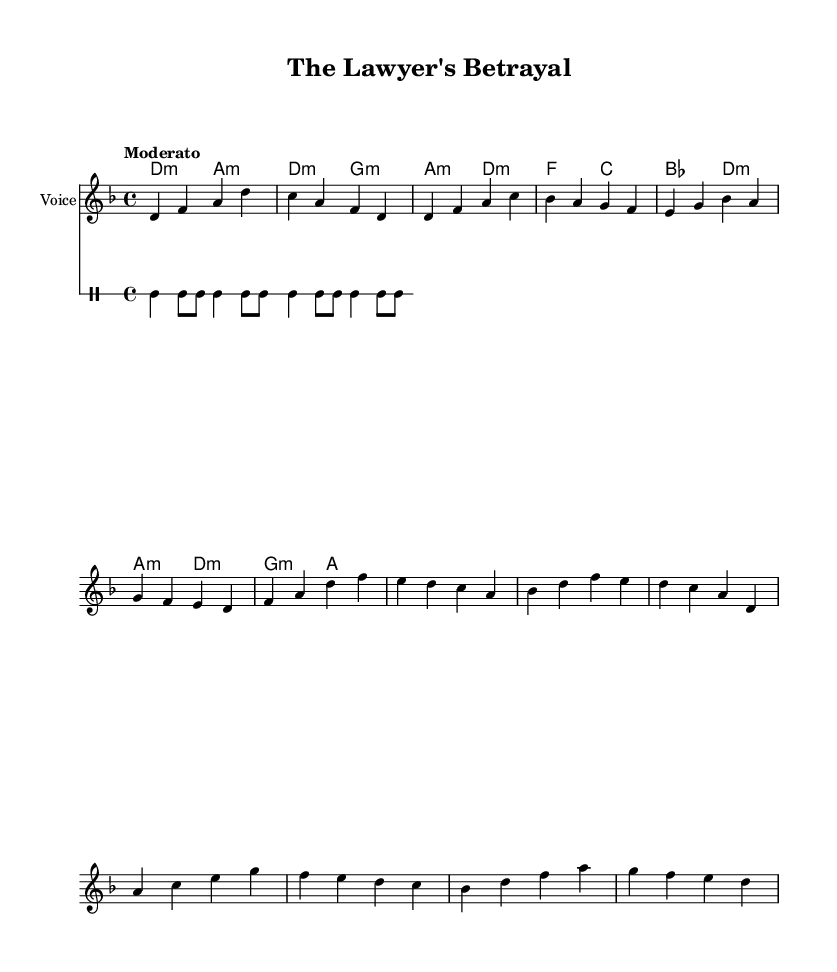What is the key signature of this music? The key signature is D minor, which has one flat. Looking at the global settings in the provided code, it clearly states '\key d \minor' indicating that D minor is the key.
Answer: D minor What is the time signature of this music? The time signature is 4/4, which is indicated by the global settings in the code section with '\time 4/4'. This means there are four beats per measure.
Answer: 4/4 What is the tempo marking in this music? The tempo marking is Moderato, as stated in the global section of the provided code. This term generally indicates a moderate pace for the performance.
Answer: Moderato Which section includes the phrase "Oh, the lawyer's betrayal"? The phrase "Oh, the lawyer's betrayal" is part of the chorus, indicated by the presence of 'chorusWords' in the code and the layout revealing its position in the song structure.
Answer: Chorus What is the overall theme expressed in the lyrics? The overall theme expressed in the lyrics revolves around betrayal, with particular emphasis on the experience of being misled by a lawyer, as encapsulated in phrases like "trusted you with all I had" and "warning others of the pain". This highlights personal experiences of trust and deception.
Answer: Betrayal What type of guitar accompaniment is indicated in the sheet music? The guitar accompaniment indicated in the sheet music utilizes simple drum-like strumming patterns, designed to create a rhythmic background for the vocal melody, as seen in the guitarStrumming section.
Answer: Percussion-style 